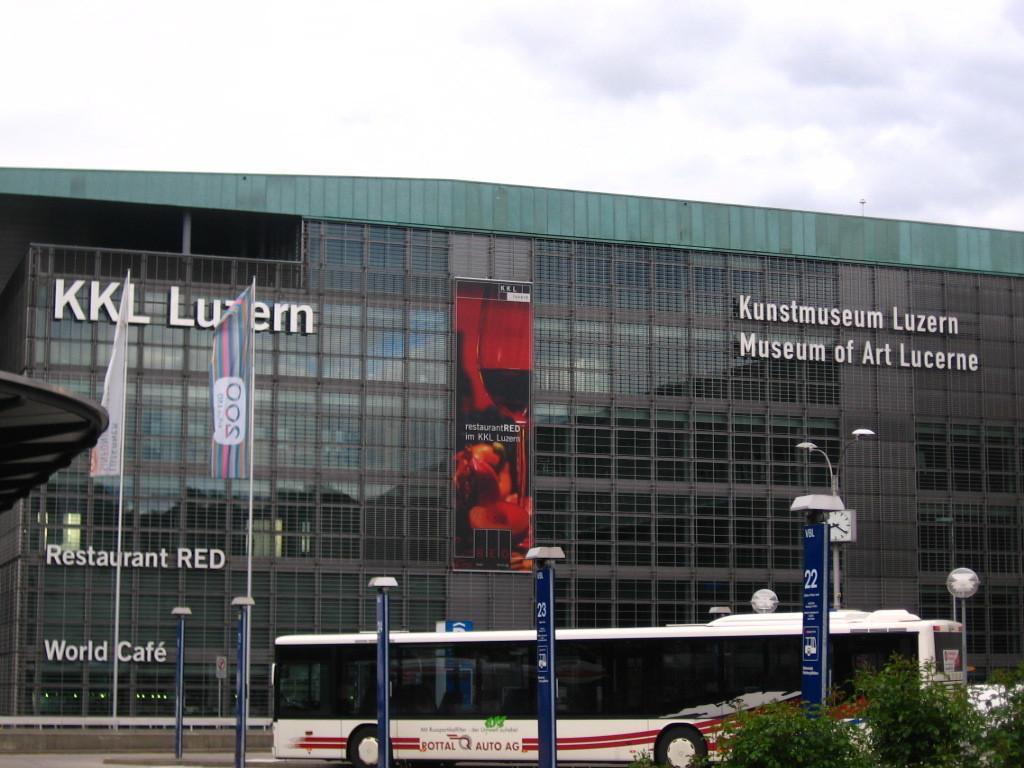Can you describe this image briefly? In this image we can see a building, on the building we can see a board and some text, there are some flags, trees, poles, lights and a vehicle, in the background we can see the sky with clouds. 